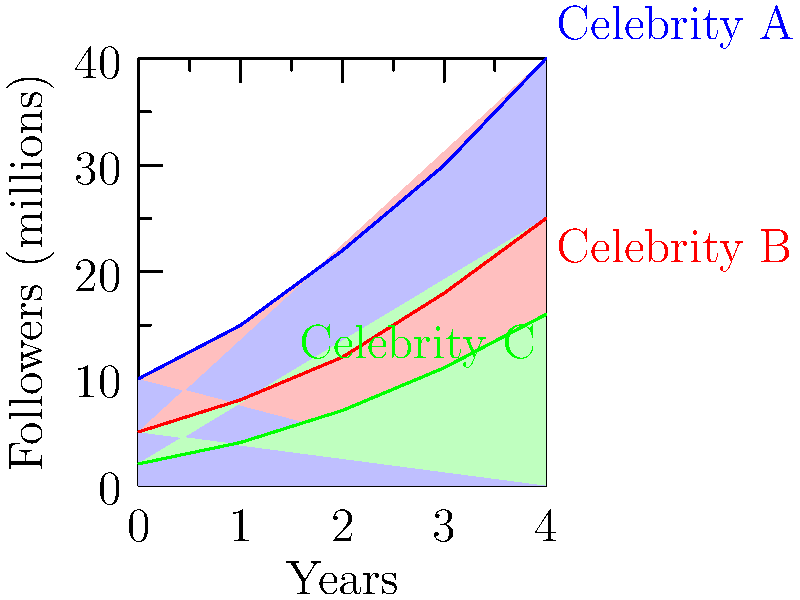As a radio personality who often interviews celebrities, you're analyzing the social media growth of three celebrities over a 4-year period. The stacked area chart shows their follower count in millions. Which celebrity had the most consistent year-over-year growth rate, and how might this impact your interview strategy? To determine which celebrity had the most consistent year-over-year growth rate, we need to calculate the growth rate for each celebrity for each year and compare the variations:

1. Calculate year-over-year growth rates:
   Celebrity A: (15-10)/10 = 50%, (22-15)/15 ≈ 47%, (30-22)/22 ≈ 36%, (40-30)/30 ≈ 33%
   Celebrity B: (8-5)/5 = 60%, (12-8)/8 = 50%, (18-12)/12 = 50%, (25-18)/18 ≈ 39%
   Celebrity C: (4-2)/2 = 100%, (7-4)/4 = 75%, (11-7)/7 ≈ 57%, (16-11)/11 ≈ 45%

2. Analyze the variations:
   Celebrity A: Rates vary from 33% to 50% (range of 17%)
   Celebrity B: Rates vary from 39% to 60% (range of 21%)
   Celebrity C: Rates vary from 45% to 100% (range of 55%)

3. Conclusion:
   Celebrity B has the most consistent growth rate, with three out of four years showing a 50% growth rate and the smallest range of variation.

4. Impact on interview strategy:
   When interviewing Celebrity B, you could focus on their steady growth and ask about their consistent social media strategy. For Celebrities A and C, you might inquire about specific events or changes in strategy that led to their more variable growth rates.
Answer: Celebrity B; focus on consistent strategy in interview. 